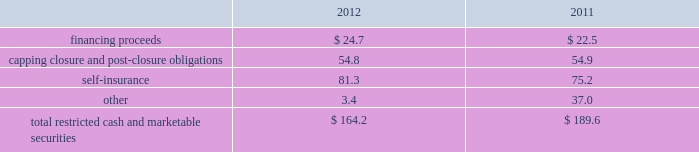Republic services , inc .
Notes to consolidated financial statements 2014 ( continued ) the letters of credit use $ 909.4 million and $ 950.2 million as of december 31 , 2012 and 2011 , respectively , of availability under our credit facilities .
Surety bonds expire on various dates through 2026 .
These financial instruments are issued in the normal course of business and are not debt .
Because we currently have no liability for this financial assurance , it is not reflected in our consolidated balance sheets .
However , we have recorded capping , closure and post-closure obligations and self-insurance reserves as they are incurred .
The underlying financial assurance obligations , in excess of those already reflected in our consolidated balance sheets , would be recorded if it is probable that we would be unable to fulfill our related obligations .
We do not expect this to occur .
Our restricted cash and marketable securities deposits include , among other things , restricted cash and marketable securities held for capital expenditures under certain debt facilities , and restricted cash and marketable securities pledged to regulatory agencies and governmental entities as financial guarantees of our performance related to our final capping , closure and post-closure obligations at our landfills .
The table summarizes our restricted cash and marketable securities as of december 31: .
We own a 19.9% ( 19.9 % ) interest in a company that , among other activities , issues financial surety bonds to secure capping , closure and post-closure obligations for companies operating in the solid waste industry .
We account for this investment under the cost method of accounting .
There have been no identified events or changes in circumstances that may have a significant adverse effect on the recoverability of the investment .
This investee company and the parent company of the investee had written surety bonds for us relating primarily to our landfill operations for capping , closure and post-closure , of which $ 1152.1 million was outstanding as of december 31 , 2012 .
Our reimbursement obligations under these bonds are secured by an indemnity agreement with the investee and letters of credit totaling $ 23.4 million and $ 45.0 million as of december 31 , 2012 and 2011 .
Off-balance sheet arrangements we have no off-balance sheet debt or similar obligations , other than operating leases and the financial assurances discussed above , which are not classified as debt .
We have no transactions or obligations with related parties that are not disclosed , consolidated into or reflected in our reported financial position or results of operations .
We have not guaranteed any third-party debt .
Guarantees we enter into contracts in the normal course of business that include indemnification clauses .
Indemnifications relating to known liabilities are recorded in the consolidated financial statements based on our best estimate of required future payments .
Certain of these indemnifications relate to contingent events or occurrences , such as the imposition of additional taxes due to a change in the tax law or adverse interpretation of the tax law , and indemnifications made in divestiture agreements where we indemnify the buyer for liabilities that relate to our activities prior to the divestiture and that may become known in the future .
We do not believe that these contingent obligations will have a material effect on our consolidated financial position , results of operations or cash flows. .
Ar december 31 , 2012 what was the ratio of the surety bond to the reimbursement obligation under the surety bonds? 
Rationale: for every dollar of reimbursement obligation there was $ 4.9 for the surety bond
Computations: (1152.1 / 23.4)
Answer: 49.23504. 